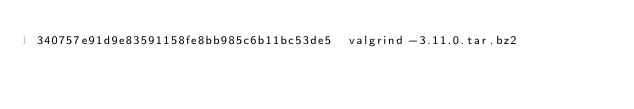<code> <loc_0><loc_0><loc_500><loc_500><_SML_>340757e91d9e83591158fe8bb985c6b11bc53de5  valgrind-3.11.0.tar.bz2
</code> 